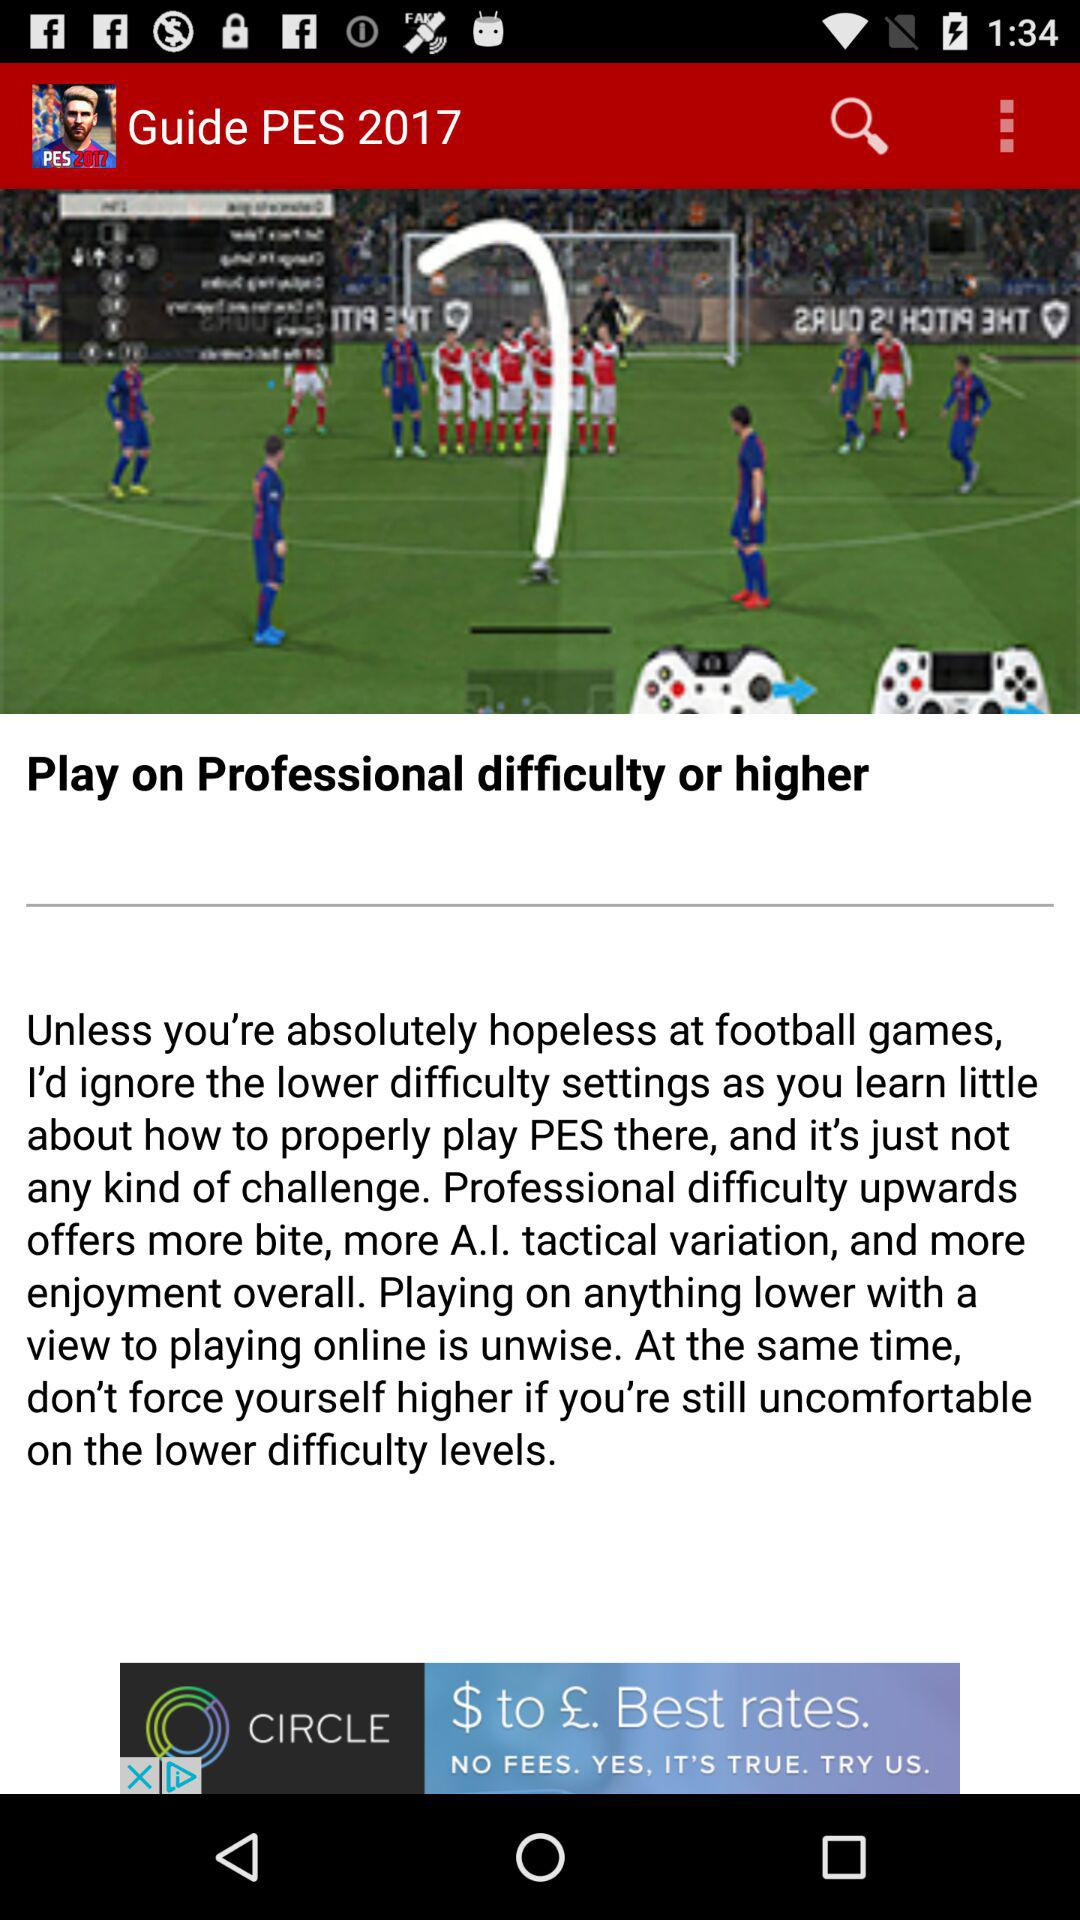How many pages are in the guide?
When the provided information is insufficient, respond with <no answer>. <no answer> 